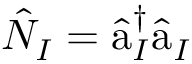Convert formula to latex. <formula><loc_0><loc_0><loc_500><loc_500>\hat { N } _ { I } = \hat { a } _ { I } ^ { \dagger } \hat { a } _ { I }</formula> 